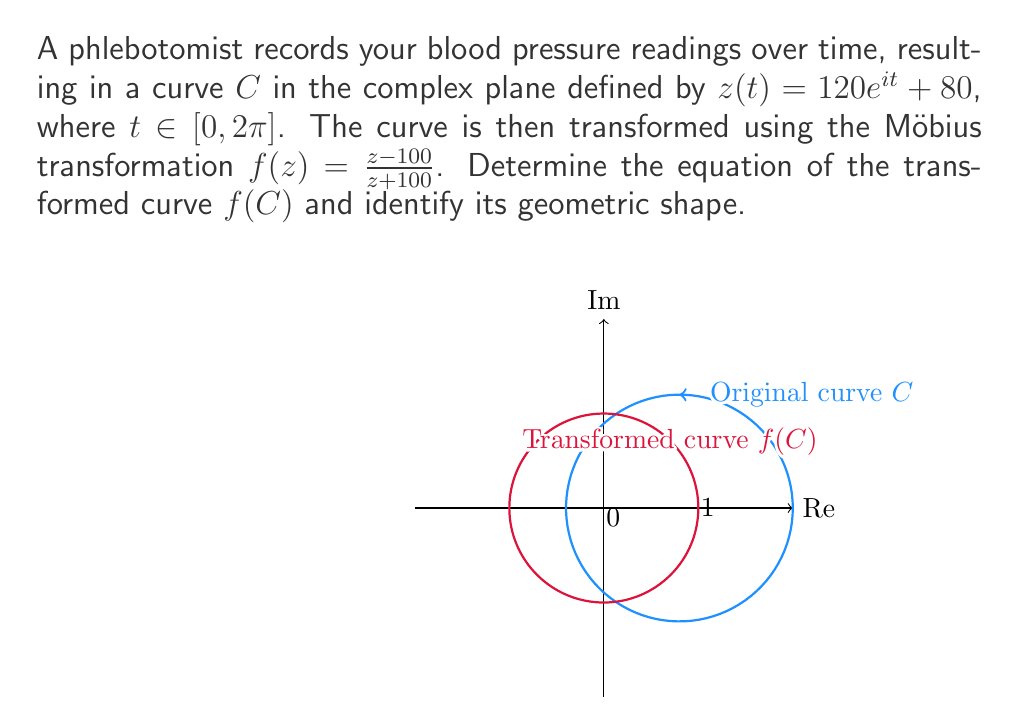Solve this math problem. Let's approach this step-by-step:

1) The original curve $C$ is given by $z(t) = 120e^{it} + 80$, which is a circle with center at 80 and radius 120.

2) The Möbius transformation is $f(z) = \frac{z-100}{z+100}$.

3) To find the transformed curve, we substitute $z(t)$ into $f(z)$:

   $$f(z(t)) = \frac{(120e^{it} + 80) - 100}{(120e^{it} + 80) + 100}$$

4) Simplify:
   $$f(z(t)) = \frac{120e^{it} - 20}{120e^{it} + 180}$$

5) Divide numerator and denominator by $120e^{it}$:
   $$f(z(t)) = \frac{1 - \frac{20}{120e^{it}}}{1 + \frac{180}{120e^{it}}} = \frac{1 - \frac{1}{6e^{it}}}{1 + \frac{3}{2e^{it}}}$$

6) Let $w = e^{it}$. Then the equation becomes:
   $$f(w) = \frac{1 - \frac{1}{6w}}{1 + \frac{3}{2w}} = \frac{6w - 1}{6w + 9}$$

7) This is of the form $\frac{aw+b}{cw+d}$, where $a=6$, $b=-1$, $c=6$, and $d=9$.

8) For a Möbius transformation of this form, if $ad-bc \neq 0$, the image is a circle. Here:
   $$ad-bc = 6(9) - (-1)(6) = 60 \neq 0$$

9) Therefore, the transformed curve $f(C)$ is a circle.

10) To find its center and radius, we can use the formula:
    Center: $\frac{a\bar{d}-b\bar{c}}{|c|^2-|a|^2}$
    Radius: $\frac{|ad-bc|}{||c|^2-|a|^2|}$

11) Calculating:
    Center = $\frac{6(9)-(-1)(6)}{6^2-6^2} = \frac{60}{0}$, which is undefined.
    Radius = $\frac{|60|}{|6^2-6^2|} = \frac{60}{0}$, which is also undefined.

12) When this happens, it means the circle passes through the point at infinity, making it a line in the complex plane.

13) To find this line, we can set $f(z) = k$, where $k$ is a constant:
    $$\frac{z-100}{z+100} = k$$
    $$z-100 = kz+100k$$
    $$z(1-k) = 100(1+k)$$
    $$z = \frac{100(1+k)}{1-k}$$

14) This represents a vertical line in the complex plane with real part equal to 100.
Answer: $f(C)$ is the vertical line $Re(z) = 100$ in the complex plane. 